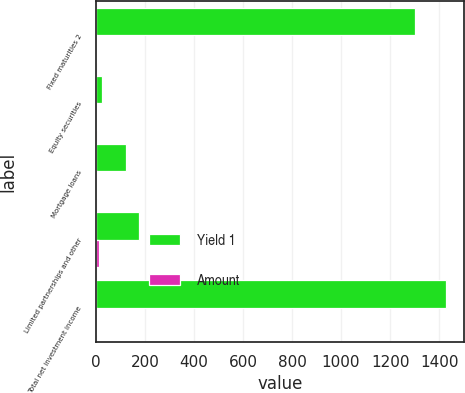<chart> <loc_0><loc_0><loc_500><loc_500><stacked_bar_chart><ecel><fcel>Fixed maturities 2<fcel>Equity securities<fcel>Mortgage loans<fcel>Limited partnerships and other<fcel>Total net investment income<nl><fcel>Yield 1<fcel>1303<fcel>24<fcel>124<fcel>174<fcel>1429<nl><fcel>Amount<fcel>3.9<fcel>2.8<fcel>4.1<fcel>12<fcel>3.7<nl></chart> 